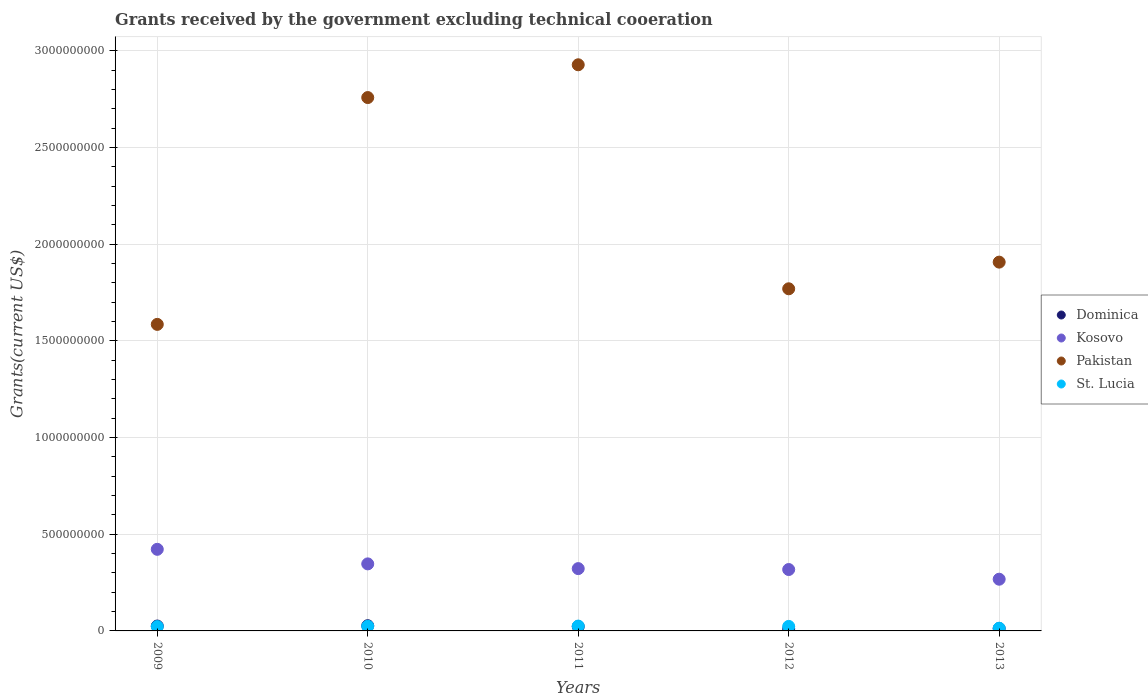What is the total grants received by the government in Pakistan in 2012?
Give a very brief answer. 1.77e+09. Across all years, what is the maximum total grants received by the government in Pakistan?
Offer a terse response. 2.93e+09. Across all years, what is the minimum total grants received by the government in Dominica?
Provide a short and direct response. 1.07e+07. What is the total total grants received by the government in Kosovo in the graph?
Offer a very short reply. 1.68e+09. What is the difference between the total grants received by the government in Kosovo in 2009 and that in 2011?
Provide a short and direct response. 9.97e+07. What is the difference between the total grants received by the government in St. Lucia in 2011 and the total grants received by the government in Dominica in 2013?
Provide a succinct answer. 1.26e+07. What is the average total grants received by the government in Dominica per year?
Your answer should be compact. 1.96e+07. In the year 2010, what is the difference between the total grants received by the government in St. Lucia and total grants received by the government in Kosovo?
Your answer should be compact. -3.23e+08. What is the ratio of the total grants received by the government in Pakistan in 2011 to that in 2013?
Keep it short and to the point. 1.54. Is the total grants received by the government in St. Lucia in 2010 less than that in 2012?
Offer a terse response. No. Is the difference between the total grants received by the government in St. Lucia in 2010 and 2012 greater than the difference between the total grants received by the government in Kosovo in 2010 and 2012?
Keep it short and to the point. No. What is the difference between the highest and the second highest total grants received by the government in Dominica?
Give a very brief answer. 1.62e+06. What is the difference between the highest and the lowest total grants received by the government in Pakistan?
Offer a terse response. 1.34e+09. Is the sum of the total grants received by the government in Pakistan in 2010 and 2011 greater than the maximum total grants received by the government in Kosovo across all years?
Provide a succinct answer. Yes. Is it the case that in every year, the sum of the total grants received by the government in St. Lucia and total grants received by the government in Pakistan  is greater than the sum of total grants received by the government in Dominica and total grants received by the government in Kosovo?
Provide a succinct answer. Yes. Is it the case that in every year, the sum of the total grants received by the government in Pakistan and total grants received by the government in St. Lucia  is greater than the total grants received by the government in Kosovo?
Ensure brevity in your answer.  Yes. Does the total grants received by the government in Dominica monotonically increase over the years?
Provide a succinct answer. No. Is the total grants received by the government in Dominica strictly greater than the total grants received by the government in Pakistan over the years?
Your answer should be compact. No. Is the total grants received by the government in Kosovo strictly less than the total grants received by the government in Dominica over the years?
Keep it short and to the point. No. How many years are there in the graph?
Ensure brevity in your answer.  5. Are the values on the major ticks of Y-axis written in scientific E-notation?
Offer a very short reply. No. How are the legend labels stacked?
Give a very brief answer. Vertical. What is the title of the graph?
Offer a very short reply. Grants received by the government excluding technical cooeration. What is the label or title of the X-axis?
Your response must be concise. Years. What is the label or title of the Y-axis?
Make the answer very short. Grants(current US$). What is the Grants(current US$) of Dominica in 2009?
Make the answer very short. 2.53e+07. What is the Grants(current US$) in Kosovo in 2009?
Keep it short and to the point. 4.22e+08. What is the Grants(current US$) in Pakistan in 2009?
Make the answer very short. 1.58e+09. What is the Grants(current US$) of St. Lucia in 2009?
Offer a very short reply. 2.24e+07. What is the Grants(current US$) of Dominica in 2010?
Keep it short and to the point. 2.69e+07. What is the Grants(current US$) in Kosovo in 2010?
Your response must be concise. 3.47e+08. What is the Grants(current US$) of Pakistan in 2010?
Ensure brevity in your answer.  2.76e+09. What is the Grants(current US$) in St. Lucia in 2010?
Offer a very short reply. 2.39e+07. What is the Grants(current US$) in Dominica in 2011?
Keep it short and to the point. 2.28e+07. What is the Grants(current US$) of Kosovo in 2011?
Your answer should be very brief. 3.22e+08. What is the Grants(current US$) in Pakistan in 2011?
Offer a terse response. 2.93e+09. What is the Grants(current US$) in St. Lucia in 2011?
Offer a very short reply. 2.50e+07. What is the Grants(current US$) in Dominica in 2012?
Your answer should be compact. 1.07e+07. What is the Grants(current US$) of Kosovo in 2012?
Make the answer very short. 3.17e+08. What is the Grants(current US$) in Pakistan in 2012?
Keep it short and to the point. 1.77e+09. What is the Grants(current US$) in St. Lucia in 2012?
Your answer should be compact. 2.34e+07. What is the Grants(current US$) in Dominica in 2013?
Your response must be concise. 1.24e+07. What is the Grants(current US$) of Kosovo in 2013?
Provide a short and direct response. 2.67e+08. What is the Grants(current US$) in Pakistan in 2013?
Keep it short and to the point. 1.91e+09. What is the Grants(current US$) of St. Lucia in 2013?
Offer a very short reply. 1.39e+07. Across all years, what is the maximum Grants(current US$) in Dominica?
Provide a short and direct response. 2.69e+07. Across all years, what is the maximum Grants(current US$) in Kosovo?
Make the answer very short. 4.22e+08. Across all years, what is the maximum Grants(current US$) of Pakistan?
Offer a terse response. 2.93e+09. Across all years, what is the maximum Grants(current US$) in St. Lucia?
Give a very brief answer. 2.50e+07. Across all years, what is the minimum Grants(current US$) in Dominica?
Provide a succinct answer. 1.07e+07. Across all years, what is the minimum Grants(current US$) in Kosovo?
Offer a terse response. 2.67e+08. Across all years, what is the minimum Grants(current US$) in Pakistan?
Your answer should be compact. 1.58e+09. Across all years, what is the minimum Grants(current US$) of St. Lucia?
Offer a terse response. 1.39e+07. What is the total Grants(current US$) in Dominica in the graph?
Give a very brief answer. 9.82e+07. What is the total Grants(current US$) in Kosovo in the graph?
Provide a succinct answer. 1.68e+09. What is the total Grants(current US$) of Pakistan in the graph?
Your response must be concise. 1.09e+1. What is the total Grants(current US$) in St. Lucia in the graph?
Offer a very short reply. 1.09e+08. What is the difference between the Grants(current US$) in Dominica in 2009 and that in 2010?
Keep it short and to the point. -1.62e+06. What is the difference between the Grants(current US$) of Kosovo in 2009 and that in 2010?
Provide a short and direct response. 7.53e+07. What is the difference between the Grants(current US$) of Pakistan in 2009 and that in 2010?
Ensure brevity in your answer.  -1.17e+09. What is the difference between the Grants(current US$) in St. Lucia in 2009 and that in 2010?
Ensure brevity in your answer.  -1.55e+06. What is the difference between the Grants(current US$) of Dominica in 2009 and that in 2011?
Your answer should be very brief. 2.53e+06. What is the difference between the Grants(current US$) in Kosovo in 2009 and that in 2011?
Ensure brevity in your answer.  9.97e+07. What is the difference between the Grants(current US$) of Pakistan in 2009 and that in 2011?
Make the answer very short. -1.34e+09. What is the difference between the Grants(current US$) of St. Lucia in 2009 and that in 2011?
Ensure brevity in your answer.  -2.63e+06. What is the difference between the Grants(current US$) of Dominica in 2009 and that in 2012?
Offer a very short reply. 1.46e+07. What is the difference between the Grants(current US$) of Kosovo in 2009 and that in 2012?
Provide a short and direct response. 1.04e+08. What is the difference between the Grants(current US$) in Pakistan in 2009 and that in 2012?
Your answer should be very brief. -1.84e+08. What is the difference between the Grants(current US$) of St. Lucia in 2009 and that in 2012?
Make the answer very short. -1.01e+06. What is the difference between the Grants(current US$) of Dominica in 2009 and that in 2013?
Provide a succinct answer. 1.29e+07. What is the difference between the Grants(current US$) of Kosovo in 2009 and that in 2013?
Provide a short and direct response. 1.55e+08. What is the difference between the Grants(current US$) in Pakistan in 2009 and that in 2013?
Make the answer very short. -3.22e+08. What is the difference between the Grants(current US$) in St. Lucia in 2009 and that in 2013?
Your answer should be very brief. 8.48e+06. What is the difference between the Grants(current US$) in Dominica in 2010 and that in 2011?
Your answer should be compact. 4.15e+06. What is the difference between the Grants(current US$) in Kosovo in 2010 and that in 2011?
Offer a very short reply. 2.44e+07. What is the difference between the Grants(current US$) of Pakistan in 2010 and that in 2011?
Your answer should be compact. -1.69e+08. What is the difference between the Grants(current US$) of St. Lucia in 2010 and that in 2011?
Give a very brief answer. -1.08e+06. What is the difference between the Grants(current US$) in Dominica in 2010 and that in 2012?
Offer a very short reply. 1.62e+07. What is the difference between the Grants(current US$) of Kosovo in 2010 and that in 2012?
Offer a terse response. 2.92e+07. What is the difference between the Grants(current US$) in Pakistan in 2010 and that in 2012?
Ensure brevity in your answer.  9.89e+08. What is the difference between the Grants(current US$) of St. Lucia in 2010 and that in 2012?
Your response must be concise. 5.40e+05. What is the difference between the Grants(current US$) in Dominica in 2010 and that in 2013?
Your answer should be very brief. 1.45e+07. What is the difference between the Grants(current US$) in Kosovo in 2010 and that in 2013?
Ensure brevity in your answer.  7.93e+07. What is the difference between the Grants(current US$) in Pakistan in 2010 and that in 2013?
Ensure brevity in your answer.  8.51e+08. What is the difference between the Grants(current US$) in St. Lucia in 2010 and that in 2013?
Provide a succinct answer. 1.00e+07. What is the difference between the Grants(current US$) of Dominica in 2011 and that in 2012?
Provide a succinct answer. 1.21e+07. What is the difference between the Grants(current US$) in Kosovo in 2011 and that in 2012?
Your answer should be compact. 4.73e+06. What is the difference between the Grants(current US$) of Pakistan in 2011 and that in 2012?
Offer a terse response. 1.16e+09. What is the difference between the Grants(current US$) of St. Lucia in 2011 and that in 2012?
Your response must be concise. 1.62e+06. What is the difference between the Grants(current US$) in Dominica in 2011 and that in 2013?
Keep it short and to the point. 1.04e+07. What is the difference between the Grants(current US$) of Kosovo in 2011 and that in 2013?
Provide a succinct answer. 5.48e+07. What is the difference between the Grants(current US$) of Pakistan in 2011 and that in 2013?
Keep it short and to the point. 1.02e+09. What is the difference between the Grants(current US$) of St. Lucia in 2011 and that in 2013?
Your answer should be very brief. 1.11e+07. What is the difference between the Grants(current US$) of Dominica in 2012 and that in 2013?
Give a very brief answer. -1.71e+06. What is the difference between the Grants(current US$) in Kosovo in 2012 and that in 2013?
Provide a succinct answer. 5.01e+07. What is the difference between the Grants(current US$) in Pakistan in 2012 and that in 2013?
Offer a terse response. -1.38e+08. What is the difference between the Grants(current US$) in St. Lucia in 2012 and that in 2013?
Make the answer very short. 9.49e+06. What is the difference between the Grants(current US$) of Dominica in 2009 and the Grants(current US$) of Kosovo in 2010?
Offer a very short reply. -3.21e+08. What is the difference between the Grants(current US$) in Dominica in 2009 and the Grants(current US$) in Pakistan in 2010?
Offer a terse response. -2.73e+09. What is the difference between the Grants(current US$) in Dominica in 2009 and the Grants(current US$) in St. Lucia in 2010?
Give a very brief answer. 1.39e+06. What is the difference between the Grants(current US$) in Kosovo in 2009 and the Grants(current US$) in Pakistan in 2010?
Your answer should be compact. -2.34e+09. What is the difference between the Grants(current US$) in Kosovo in 2009 and the Grants(current US$) in St. Lucia in 2010?
Offer a terse response. 3.98e+08. What is the difference between the Grants(current US$) in Pakistan in 2009 and the Grants(current US$) in St. Lucia in 2010?
Your answer should be compact. 1.56e+09. What is the difference between the Grants(current US$) in Dominica in 2009 and the Grants(current US$) in Kosovo in 2011?
Make the answer very short. -2.97e+08. What is the difference between the Grants(current US$) in Dominica in 2009 and the Grants(current US$) in Pakistan in 2011?
Give a very brief answer. -2.90e+09. What is the difference between the Grants(current US$) of Kosovo in 2009 and the Grants(current US$) of Pakistan in 2011?
Offer a very short reply. -2.51e+09. What is the difference between the Grants(current US$) of Kosovo in 2009 and the Grants(current US$) of St. Lucia in 2011?
Make the answer very short. 3.97e+08. What is the difference between the Grants(current US$) of Pakistan in 2009 and the Grants(current US$) of St. Lucia in 2011?
Keep it short and to the point. 1.56e+09. What is the difference between the Grants(current US$) of Dominica in 2009 and the Grants(current US$) of Kosovo in 2012?
Your answer should be very brief. -2.92e+08. What is the difference between the Grants(current US$) of Dominica in 2009 and the Grants(current US$) of Pakistan in 2012?
Offer a very short reply. -1.74e+09. What is the difference between the Grants(current US$) of Dominica in 2009 and the Grants(current US$) of St. Lucia in 2012?
Keep it short and to the point. 1.93e+06. What is the difference between the Grants(current US$) in Kosovo in 2009 and the Grants(current US$) in Pakistan in 2012?
Make the answer very short. -1.35e+09. What is the difference between the Grants(current US$) in Kosovo in 2009 and the Grants(current US$) in St. Lucia in 2012?
Your answer should be very brief. 3.99e+08. What is the difference between the Grants(current US$) in Pakistan in 2009 and the Grants(current US$) in St. Lucia in 2012?
Your response must be concise. 1.56e+09. What is the difference between the Grants(current US$) in Dominica in 2009 and the Grants(current US$) in Kosovo in 2013?
Provide a short and direct response. -2.42e+08. What is the difference between the Grants(current US$) of Dominica in 2009 and the Grants(current US$) of Pakistan in 2013?
Provide a succinct answer. -1.88e+09. What is the difference between the Grants(current US$) of Dominica in 2009 and the Grants(current US$) of St. Lucia in 2013?
Provide a short and direct response. 1.14e+07. What is the difference between the Grants(current US$) of Kosovo in 2009 and the Grants(current US$) of Pakistan in 2013?
Your response must be concise. -1.48e+09. What is the difference between the Grants(current US$) of Kosovo in 2009 and the Grants(current US$) of St. Lucia in 2013?
Offer a very short reply. 4.08e+08. What is the difference between the Grants(current US$) in Pakistan in 2009 and the Grants(current US$) in St. Lucia in 2013?
Your answer should be compact. 1.57e+09. What is the difference between the Grants(current US$) of Dominica in 2010 and the Grants(current US$) of Kosovo in 2011?
Your response must be concise. -2.95e+08. What is the difference between the Grants(current US$) of Dominica in 2010 and the Grants(current US$) of Pakistan in 2011?
Offer a terse response. -2.90e+09. What is the difference between the Grants(current US$) of Dominica in 2010 and the Grants(current US$) of St. Lucia in 2011?
Offer a terse response. 1.93e+06. What is the difference between the Grants(current US$) in Kosovo in 2010 and the Grants(current US$) in Pakistan in 2011?
Offer a very short reply. -2.58e+09. What is the difference between the Grants(current US$) in Kosovo in 2010 and the Grants(current US$) in St. Lucia in 2011?
Offer a terse response. 3.22e+08. What is the difference between the Grants(current US$) of Pakistan in 2010 and the Grants(current US$) of St. Lucia in 2011?
Offer a very short reply. 2.73e+09. What is the difference between the Grants(current US$) of Dominica in 2010 and the Grants(current US$) of Kosovo in 2012?
Provide a short and direct response. -2.91e+08. What is the difference between the Grants(current US$) in Dominica in 2010 and the Grants(current US$) in Pakistan in 2012?
Make the answer very short. -1.74e+09. What is the difference between the Grants(current US$) of Dominica in 2010 and the Grants(current US$) of St. Lucia in 2012?
Make the answer very short. 3.55e+06. What is the difference between the Grants(current US$) in Kosovo in 2010 and the Grants(current US$) in Pakistan in 2012?
Provide a succinct answer. -1.42e+09. What is the difference between the Grants(current US$) of Kosovo in 2010 and the Grants(current US$) of St. Lucia in 2012?
Ensure brevity in your answer.  3.23e+08. What is the difference between the Grants(current US$) of Pakistan in 2010 and the Grants(current US$) of St. Lucia in 2012?
Provide a short and direct response. 2.73e+09. What is the difference between the Grants(current US$) in Dominica in 2010 and the Grants(current US$) in Kosovo in 2013?
Make the answer very short. -2.40e+08. What is the difference between the Grants(current US$) of Dominica in 2010 and the Grants(current US$) of Pakistan in 2013?
Offer a very short reply. -1.88e+09. What is the difference between the Grants(current US$) in Dominica in 2010 and the Grants(current US$) in St. Lucia in 2013?
Provide a succinct answer. 1.30e+07. What is the difference between the Grants(current US$) in Kosovo in 2010 and the Grants(current US$) in Pakistan in 2013?
Offer a terse response. -1.56e+09. What is the difference between the Grants(current US$) of Kosovo in 2010 and the Grants(current US$) of St. Lucia in 2013?
Provide a short and direct response. 3.33e+08. What is the difference between the Grants(current US$) in Pakistan in 2010 and the Grants(current US$) in St. Lucia in 2013?
Make the answer very short. 2.74e+09. What is the difference between the Grants(current US$) of Dominica in 2011 and the Grants(current US$) of Kosovo in 2012?
Offer a very short reply. -2.95e+08. What is the difference between the Grants(current US$) of Dominica in 2011 and the Grants(current US$) of Pakistan in 2012?
Offer a very short reply. -1.75e+09. What is the difference between the Grants(current US$) of Dominica in 2011 and the Grants(current US$) of St. Lucia in 2012?
Keep it short and to the point. -6.00e+05. What is the difference between the Grants(current US$) in Kosovo in 2011 and the Grants(current US$) in Pakistan in 2012?
Give a very brief answer. -1.45e+09. What is the difference between the Grants(current US$) of Kosovo in 2011 and the Grants(current US$) of St. Lucia in 2012?
Your response must be concise. 2.99e+08. What is the difference between the Grants(current US$) of Pakistan in 2011 and the Grants(current US$) of St. Lucia in 2012?
Keep it short and to the point. 2.90e+09. What is the difference between the Grants(current US$) in Dominica in 2011 and the Grants(current US$) in Kosovo in 2013?
Keep it short and to the point. -2.45e+08. What is the difference between the Grants(current US$) of Dominica in 2011 and the Grants(current US$) of Pakistan in 2013?
Your answer should be compact. -1.88e+09. What is the difference between the Grants(current US$) of Dominica in 2011 and the Grants(current US$) of St. Lucia in 2013?
Offer a very short reply. 8.89e+06. What is the difference between the Grants(current US$) of Kosovo in 2011 and the Grants(current US$) of Pakistan in 2013?
Offer a terse response. -1.58e+09. What is the difference between the Grants(current US$) of Kosovo in 2011 and the Grants(current US$) of St. Lucia in 2013?
Your answer should be compact. 3.08e+08. What is the difference between the Grants(current US$) in Pakistan in 2011 and the Grants(current US$) in St. Lucia in 2013?
Make the answer very short. 2.91e+09. What is the difference between the Grants(current US$) in Dominica in 2012 and the Grants(current US$) in Kosovo in 2013?
Provide a succinct answer. -2.57e+08. What is the difference between the Grants(current US$) in Dominica in 2012 and the Grants(current US$) in Pakistan in 2013?
Provide a short and direct response. -1.90e+09. What is the difference between the Grants(current US$) of Dominica in 2012 and the Grants(current US$) of St. Lucia in 2013?
Offer a terse response. -3.20e+06. What is the difference between the Grants(current US$) of Kosovo in 2012 and the Grants(current US$) of Pakistan in 2013?
Your answer should be compact. -1.59e+09. What is the difference between the Grants(current US$) of Kosovo in 2012 and the Grants(current US$) of St. Lucia in 2013?
Provide a succinct answer. 3.04e+08. What is the difference between the Grants(current US$) of Pakistan in 2012 and the Grants(current US$) of St. Lucia in 2013?
Your answer should be very brief. 1.76e+09. What is the average Grants(current US$) of Dominica per year?
Keep it short and to the point. 1.96e+07. What is the average Grants(current US$) in Kosovo per year?
Your answer should be very brief. 3.35e+08. What is the average Grants(current US$) in Pakistan per year?
Provide a short and direct response. 2.19e+09. What is the average Grants(current US$) in St. Lucia per year?
Provide a succinct answer. 2.17e+07. In the year 2009, what is the difference between the Grants(current US$) in Dominica and Grants(current US$) in Kosovo?
Offer a very short reply. -3.97e+08. In the year 2009, what is the difference between the Grants(current US$) in Dominica and Grants(current US$) in Pakistan?
Offer a terse response. -1.56e+09. In the year 2009, what is the difference between the Grants(current US$) in Dominica and Grants(current US$) in St. Lucia?
Offer a very short reply. 2.94e+06. In the year 2009, what is the difference between the Grants(current US$) of Kosovo and Grants(current US$) of Pakistan?
Your answer should be very brief. -1.16e+09. In the year 2009, what is the difference between the Grants(current US$) in Kosovo and Grants(current US$) in St. Lucia?
Offer a very short reply. 4.00e+08. In the year 2009, what is the difference between the Grants(current US$) of Pakistan and Grants(current US$) of St. Lucia?
Make the answer very short. 1.56e+09. In the year 2010, what is the difference between the Grants(current US$) of Dominica and Grants(current US$) of Kosovo?
Make the answer very short. -3.20e+08. In the year 2010, what is the difference between the Grants(current US$) in Dominica and Grants(current US$) in Pakistan?
Offer a terse response. -2.73e+09. In the year 2010, what is the difference between the Grants(current US$) of Dominica and Grants(current US$) of St. Lucia?
Your answer should be compact. 3.01e+06. In the year 2010, what is the difference between the Grants(current US$) in Kosovo and Grants(current US$) in Pakistan?
Give a very brief answer. -2.41e+09. In the year 2010, what is the difference between the Grants(current US$) in Kosovo and Grants(current US$) in St. Lucia?
Your answer should be very brief. 3.23e+08. In the year 2010, what is the difference between the Grants(current US$) in Pakistan and Grants(current US$) in St. Lucia?
Your response must be concise. 2.73e+09. In the year 2011, what is the difference between the Grants(current US$) of Dominica and Grants(current US$) of Kosovo?
Your response must be concise. -2.99e+08. In the year 2011, what is the difference between the Grants(current US$) in Dominica and Grants(current US$) in Pakistan?
Your answer should be very brief. -2.90e+09. In the year 2011, what is the difference between the Grants(current US$) of Dominica and Grants(current US$) of St. Lucia?
Ensure brevity in your answer.  -2.22e+06. In the year 2011, what is the difference between the Grants(current US$) in Kosovo and Grants(current US$) in Pakistan?
Give a very brief answer. -2.61e+09. In the year 2011, what is the difference between the Grants(current US$) in Kosovo and Grants(current US$) in St. Lucia?
Offer a terse response. 2.97e+08. In the year 2011, what is the difference between the Grants(current US$) in Pakistan and Grants(current US$) in St. Lucia?
Provide a succinct answer. 2.90e+09. In the year 2012, what is the difference between the Grants(current US$) of Dominica and Grants(current US$) of Kosovo?
Provide a succinct answer. -3.07e+08. In the year 2012, what is the difference between the Grants(current US$) of Dominica and Grants(current US$) of Pakistan?
Your response must be concise. -1.76e+09. In the year 2012, what is the difference between the Grants(current US$) of Dominica and Grants(current US$) of St. Lucia?
Offer a terse response. -1.27e+07. In the year 2012, what is the difference between the Grants(current US$) in Kosovo and Grants(current US$) in Pakistan?
Provide a succinct answer. -1.45e+09. In the year 2012, what is the difference between the Grants(current US$) of Kosovo and Grants(current US$) of St. Lucia?
Offer a very short reply. 2.94e+08. In the year 2012, what is the difference between the Grants(current US$) in Pakistan and Grants(current US$) in St. Lucia?
Keep it short and to the point. 1.75e+09. In the year 2013, what is the difference between the Grants(current US$) of Dominica and Grants(current US$) of Kosovo?
Give a very brief answer. -2.55e+08. In the year 2013, what is the difference between the Grants(current US$) of Dominica and Grants(current US$) of Pakistan?
Make the answer very short. -1.89e+09. In the year 2013, what is the difference between the Grants(current US$) of Dominica and Grants(current US$) of St. Lucia?
Offer a very short reply. -1.49e+06. In the year 2013, what is the difference between the Grants(current US$) of Kosovo and Grants(current US$) of Pakistan?
Give a very brief answer. -1.64e+09. In the year 2013, what is the difference between the Grants(current US$) of Kosovo and Grants(current US$) of St. Lucia?
Give a very brief answer. 2.53e+08. In the year 2013, what is the difference between the Grants(current US$) in Pakistan and Grants(current US$) in St. Lucia?
Your answer should be very brief. 1.89e+09. What is the ratio of the Grants(current US$) in Dominica in 2009 to that in 2010?
Provide a succinct answer. 0.94. What is the ratio of the Grants(current US$) in Kosovo in 2009 to that in 2010?
Keep it short and to the point. 1.22. What is the ratio of the Grants(current US$) in Pakistan in 2009 to that in 2010?
Your answer should be compact. 0.57. What is the ratio of the Grants(current US$) in St. Lucia in 2009 to that in 2010?
Provide a short and direct response. 0.94. What is the ratio of the Grants(current US$) in Dominica in 2009 to that in 2011?
Your response must be concise. 1.11. What is the ratio of the Grants(current US$) in Kosovo in 2009 to that in 2011?
Ensure brevity in your answer.  1.31. What is the ratio of the Grants(current US$) of Pakistan in 2009 to that in 2011?
Offer a very short reply. 0.54. What is the ratio of the Grants(current US$) of St. Lucia in 2009 to that in 2011?
Make the answer very short. 0.89. What is the ratio of the Grants(current US$) in Dominica in 2009 to that in 2012?
Keep it short and to the point. 2.37. What is the ratio of the Grants(current US$) in Kosovo in 2009 to that in 2012?
Provide a succinct answer. 1.33. What is the ratio of the Grants(current US$) of Pakistan in 2009 to that in 2012?
Your answer should be compact. 0.9. What is the ratio of the Grants(current US$) of St. Lucia in 2009 to that in 2012?
Your answer should be very brief. 0.96. What is the ratio of the Grants(current US$) in Dominica in 2009 to that in 2013?
Keep it short and to the point. 2.04. What is the ratio of the Grants(current US$) in Kosovo in 2009 to that in 2013?
Ensure brevity in your answer.  1.58. What is the ratio of the Grants(current US$) of Pakistan in 2009 to that in 2013?
Make the answer very short. 0.83. What is the ratio of the Grants(current US$) of St. Lucia in 2009 to that in 2013?
Offer a terse response. 1.61. What is the ratio of the Grants(current US$) of Dominica in 2010 to that in 2011?
Make the answer very short. 1.18. What is the ratio of the Grants(current US$) in Kosovo in 2010 to that in 2011?
Your answer should be compact. 1.08. What is the ratio of the Grants(current US$) of Pakistan in 2010 to that in 2011?
Ensure brevity in your answer.  0.94. What is the ratio of the Grants(current US$) in St. Lucia in 2010 to that in 2011?
Your response must be concise. 0.96. What is the ratio of the Grants(current US$) in Dominica in 2010 to that in 2012?
Your response must be concise. 2.52. What is the ratio of the Grants(current US$) in Kosovo in 2010 to that in 2012?
Give a very brief answer. 1.09. What is the ratio of the Grants(current US$) of Pakistan in 2010 to that in 2012?
Provide a succinct answer. 1.56. What is the ratio of the Grants(current US$) in St. Lucia in 2010 to that in 2012?
Your response must be concise. 1.02. What is the ratio of the Grants(current US$) in Dominica in 2010 to that in 2013?
Keep it short and to the point. 2.17. What is the ratio of the Grants(current US$) of Kosovo in 2010 to that in 2013?
Offer a very short reply. 1.3. What is the ratio of the Grants(current US$) of Pakistan in 2010 to that in 2013?
Keep it short and to the point. 1.45. What is the ratio of the Grants(current US$) of St. Lucia in 2010 to that in 2013?
Provide a short and direct response. 1.72. What is the ratio of the Grants(current US$) of Dominica in 2011 to that in 2012?
Your answer should be compact. 2.13. What is the ratio of the Grants(current US$) of Kosovo in 2011 to that in 2012?
Your answer should be very brief. 1.01. What is the ratio of the Grants(current US$) in Pakistan in 2011 to that in 2012?
Offer a very short reply. 1.65. What is the ratio of the Grants(current US$) of St. Lucia in 2011 to that in 2012?
Your answer should be very brief. 1.07. What is the ratio of the Grants(current US$) in Dominica in 2011 to that in 2013?
Offer a very short reply. 1.84. What is the ratio of the Grants(current US$) of Kosovo in 2011 to that in 2013?
Your response must be concise. 1.21. What is the ratio of the Grants(current US$) in Pakistan in 2011 to that in 2013?
Keep it short and to the point. 1.54. What is the ratio of the Grants(current US$) in St. Lucia in 2011 to that in 2013?
Your answer should be very brief. 1.8. What is the ratio of the Grants(current US$) in Dominica in 2012 to that in 2013?
Your response must be concise. 0.86. What is the ratio of the Grants(current US$) of Kosovo in 2012 to that in 2013?
Your response must be concise. 1.19. What is the ratio of the Grants(current US$) of Pakistan in 2012 to that in 2013?
Offer a very short reply. 0.93. What is the ratio of the Grants(current US$) of St. Lucia in 2012 to that in 2013?
Keep it short and to the point. 1.68. What is the difference between the highest and the second highest Grants(current US$) in Dominica?
Your answer should be very brief. 1.62e+06. What is the difference between the highest and the second highest Grants(current US$) in Kosovo?
Your response must be concise. 7.53e+07. What is the difference between the highest and the second highest Grants(current US$) in Pakistan?
Offer a terse response. 1.69e+08. What is the difference between the highest and the second highest Grants(current US$) of St. Lucia?
Offer a very short reply. 1.08e+06. What is the difference between the highest and the lowest Grants(current US$) of Dominica?
Offer a terse response. 1.62e+07. What is the difference between the highest and the lowest Grants(current US$) in Kosovo?
Offer a terse response. 1.55e+08. What is the difference between the highest and the lowest Grants(current US$) of Pakistan?
Provide a succinct answer. 1.34e+09. What is the difference between the highest and the lowest Grants(current US$) in St. Lucia?
Make the answer very short. 1.11e+07. 